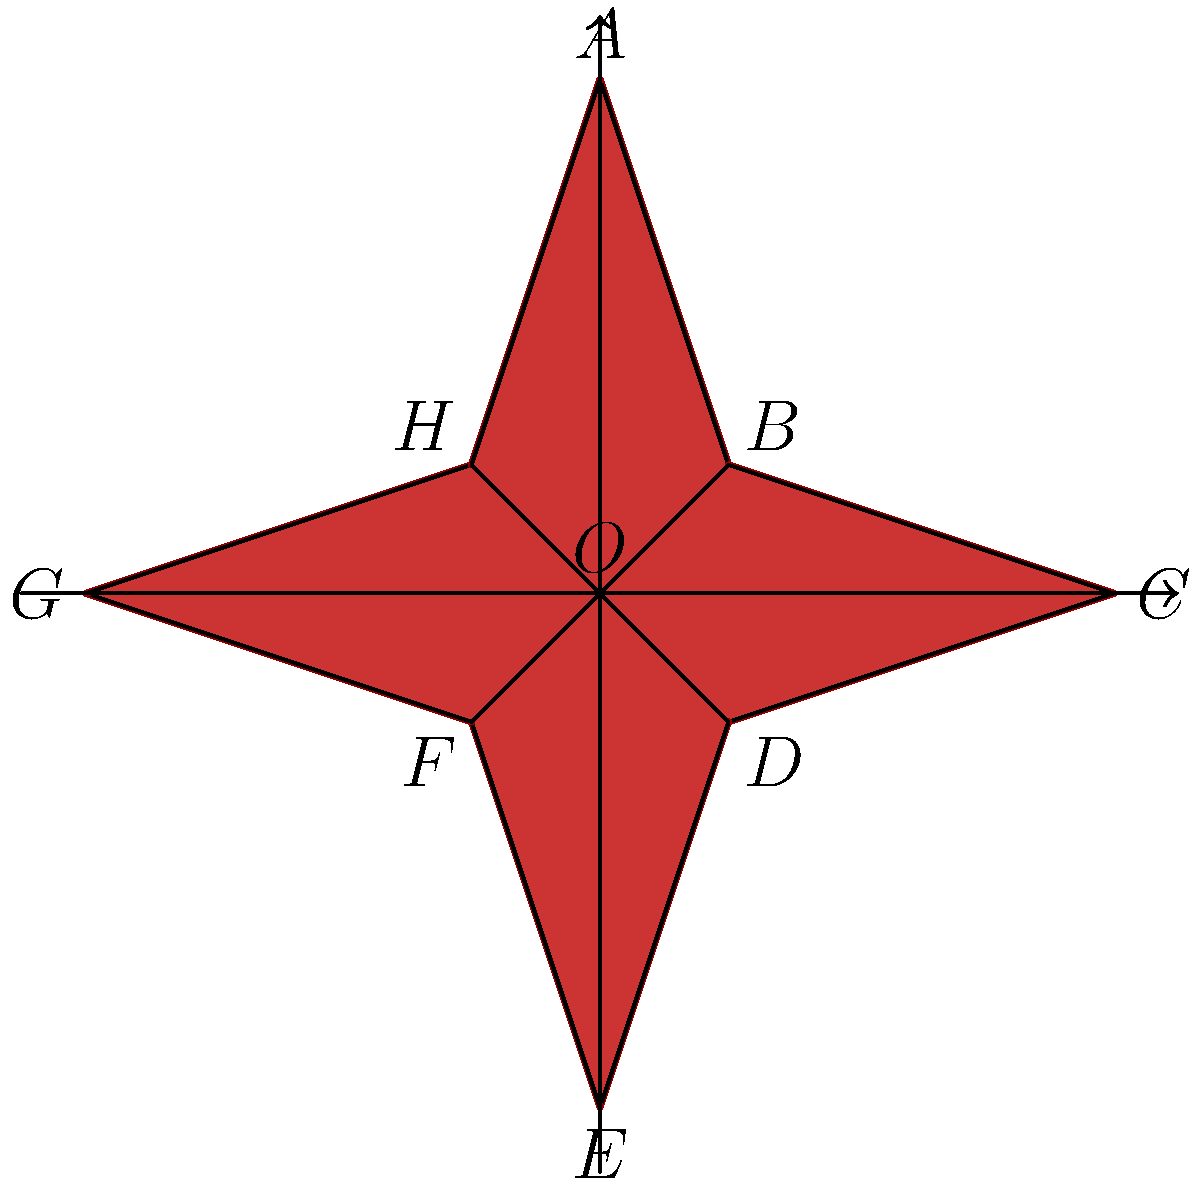Inspired by the star-shaped design on Rozzi's album cover, consider the star-shaped polygon ABCDEFGH with center O. Given that OA = 4 units, OB = OD = OF = OH = √2 units, and OC = OG = 4 units, calculate the area of the star-shaped polygon. To calculate the area of the star-shaped polygon, we'll follow these steps:

1) The star consists of 8 congruent triangles. We can calculate the area of one triangle and multiply by 8.

2) Let's focus on triangle AOB:
   - OA = 4 units
   - OB = √2 units
   - Angle AOB = 45° (since there are 8 equal parts in a full 360° rotation)

3) The area of triangle AOB can be calculated using the formula:
   $$Area_{AOB} = \frac{1}{2} \cdot OA \cdot OB \cdot \sin(AOB)$$

4) Substituting the values:
   $$Area_{AOB} = \frac{1}{2} \cdot 4 \cdot \sqrt{2} \cdot \sin(45°)$$

5) Simplify:
   $$Area_{AOB} = 2\sqrt{2} \cdot \frac{\sqrt{2}}{2} = 2$$

6) The total area of the star is 8 times this value:
   $$Area_{total} = 8 \cdot 2 = 16$$

Therefore, the area of the star-shaped polygon is 16 square units.
Answer: 16 square units 